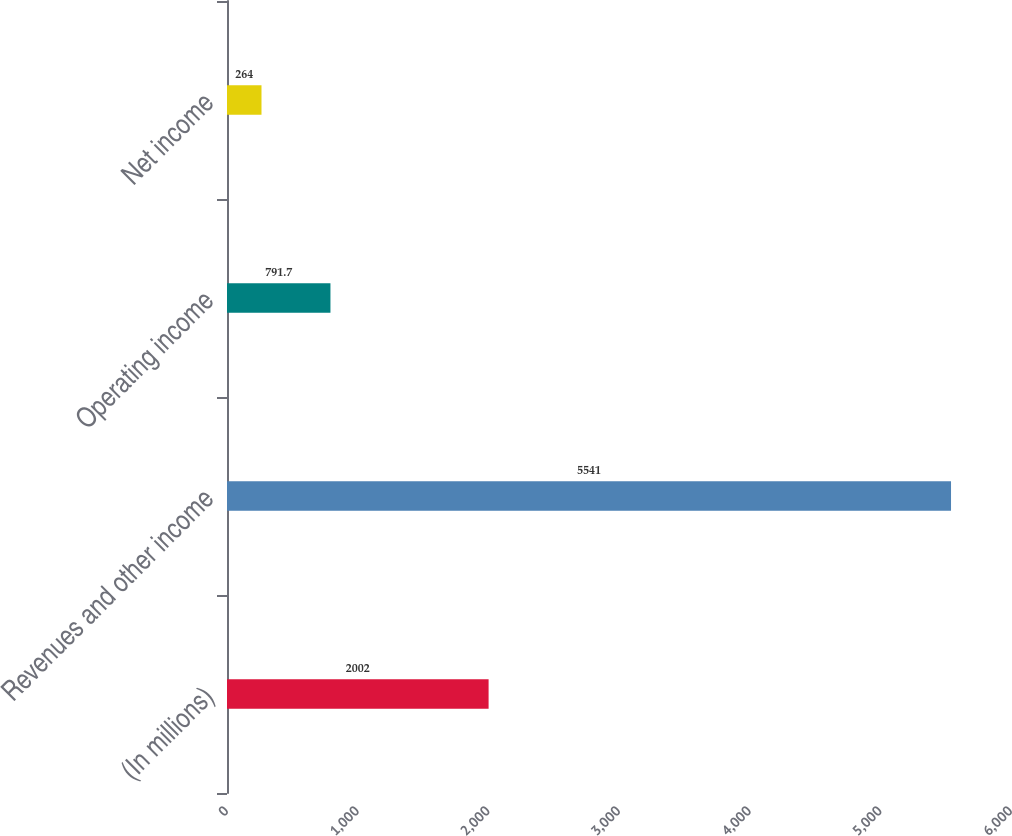Convert chart to OTSL. <chart><loc_0><loc_0><loc_500><loc_500><bar_chart><fcel>(In millions)<fcel>Revenues and other income<fcel>Operating income<fcel>Net income<nl><fcel>2002<fcel>5541<fcel>791.7<fcel>264<nl></chart> 